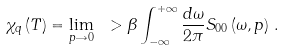<formula> <loc_0><loc_0><loc_500><loc_500>\chi _ { q } \left ( T \right ) = \lim _ { p \rightarrow 0 } \ > \beta \int _ { - \infty } ^ { + \infty } \frac { d \omega } { 2 \pi } S _ { 0 0 } \left ( \omega , p \right ) \, .</formula> 